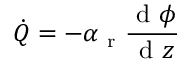Convert formula to latex. <formula><loc_0><loc_0><loc_500><loc_500>\dot { Q } = - \alpha _ { r } \frac { d \phi } { d z }</formula> 